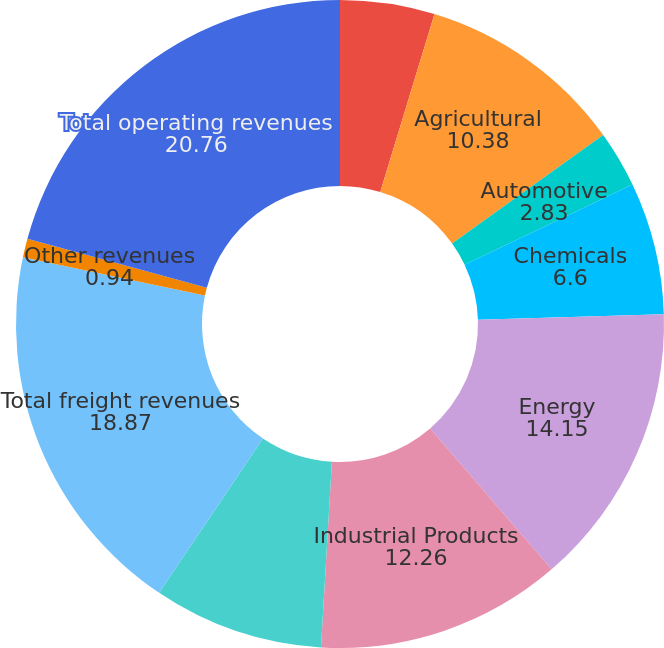<chart> <loc_0><loc_0><loc_500><loc_500><pie_chart><fcel>Millions of Dollars<fcel>Agricultural<fcel>Automotive<fcel>Chemicals<fcel>Energy<fcel>Industrial Products<fcel>Intermodal<fcel>Total freight revenues<fcel>Other revenues<fcel>Total operating revenues<nl><fcel>4.71%<fcel>10.38%<fcel>2.83%<fcel>6.6%<fcel>14.15%<fcel>12.26%<fcel>8.49%<fcel>18.87%<fcel>0.94%<fcel>20.76%<nl></chart> 